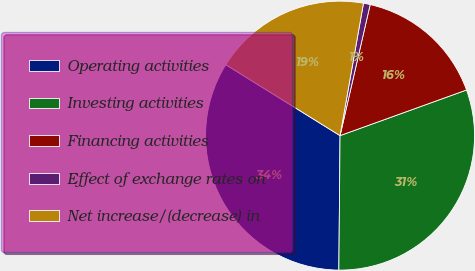Convert chart. <chart><loc_0><loc_0><loc_500><loc_500><pie_chart><fcel>Operating activities<fcel>Investing activities<fcel>Financing activities<fcel>Effect of exchange rates on<fcel>Net increase/(decrease) in<nl><fcel>33.7%<fcel>30.65%<fcel>15.89%<fcel>0.81%<fcel>18.94%<nl></chart> 